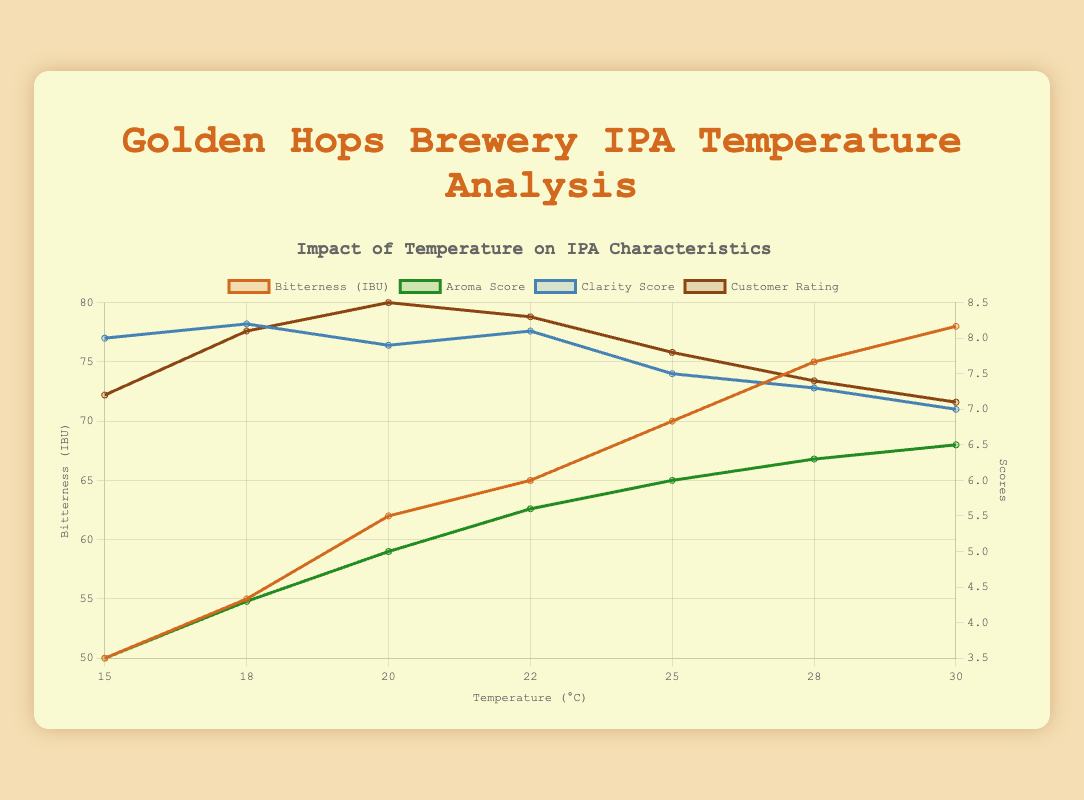What is the aroma score at 22°C? The figure shows that the aroma score at 22°C is represented by a specific point. This point corresponds to the value on the graph.
Answer: 5.6 Which temperature resulted in the highest customer rating? By examining the customer rating curve on the figure, identify the peak point and match it with the corresponding temperature on the x-axis.
Answer: 20°C How does the bitterness change from 15°C to 30°C? Compare the bitterness (IBU) values at 15°C and 30°C. Note the starting value and the ending value and calculate the difference.
Answer: Increases At what temperature does the clarity score first drop below 8.0? Locate the points on the clarity score curve to find out where it dips below 8.0 for the first time and read the corresponding temperature on the x-axis.
Answer: 25°C What is the difference in aroma score between the temperatures 18°C and 25°C? Find the aroma score at 18°C (4.3) and at 25°C (6.0) on the figure, then calculate the difference (6.0 - 4.3).
Answer: 1.7 Is the bitterness higher at 22°C or at 28°C? Compare the bitterness values at 22°C and 28°C by looking at their respective points on the bitterness curve.
Answer: 28°C What are the temperatures where the customer rating is equal to or more than 8.0? Identify the points on the customer rating curve that are at or above 8.0 and note their corresponding temperatures.
Answer: 18°C, 20°C, 22°C Which score is generally more stable across temperatures, clarity or aroma? Compare the overall fluctuations of the clarity and aroma curves to determine which has fewer fluctuations over the temperature range.
Answer: Clarity What is the average customer rating across all the temperatures? Sum the customer ratings for all temperatures and divide by the number of data points (7). Add the ratings (7.2 + 8.1 + 8.5 + 8.3 + 7.8 + 7.4 + 7.1) to get 54.4, then divide by 7.
Answer: 7.77 How much does the bitterness increase from 18°C to 25°C? Find the bitterness values at 18°C (55 IBU) and at 25°C (70 IBU), then calculate the increase (70 - 55).
Answer: 15 IBU 